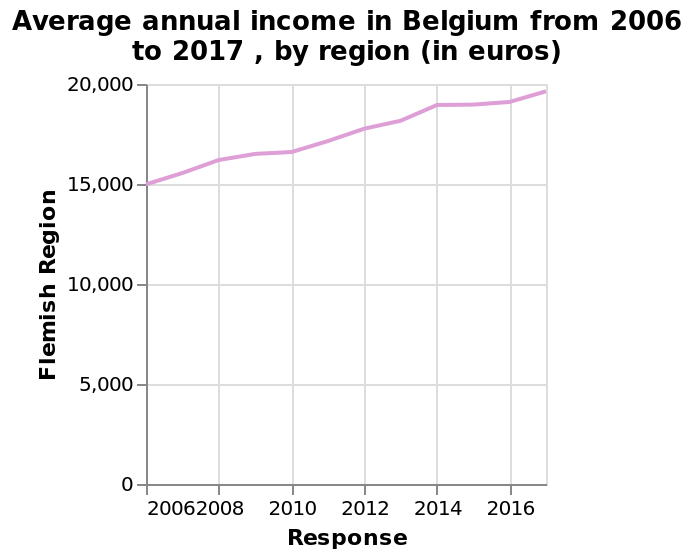<image>
What was the annual income in 2006? The annual income in 2006 was $15,000. What is the range of the y-axis on the line chart? The range of the y-axis on the line chart is from 0 to 20,000 euros. 